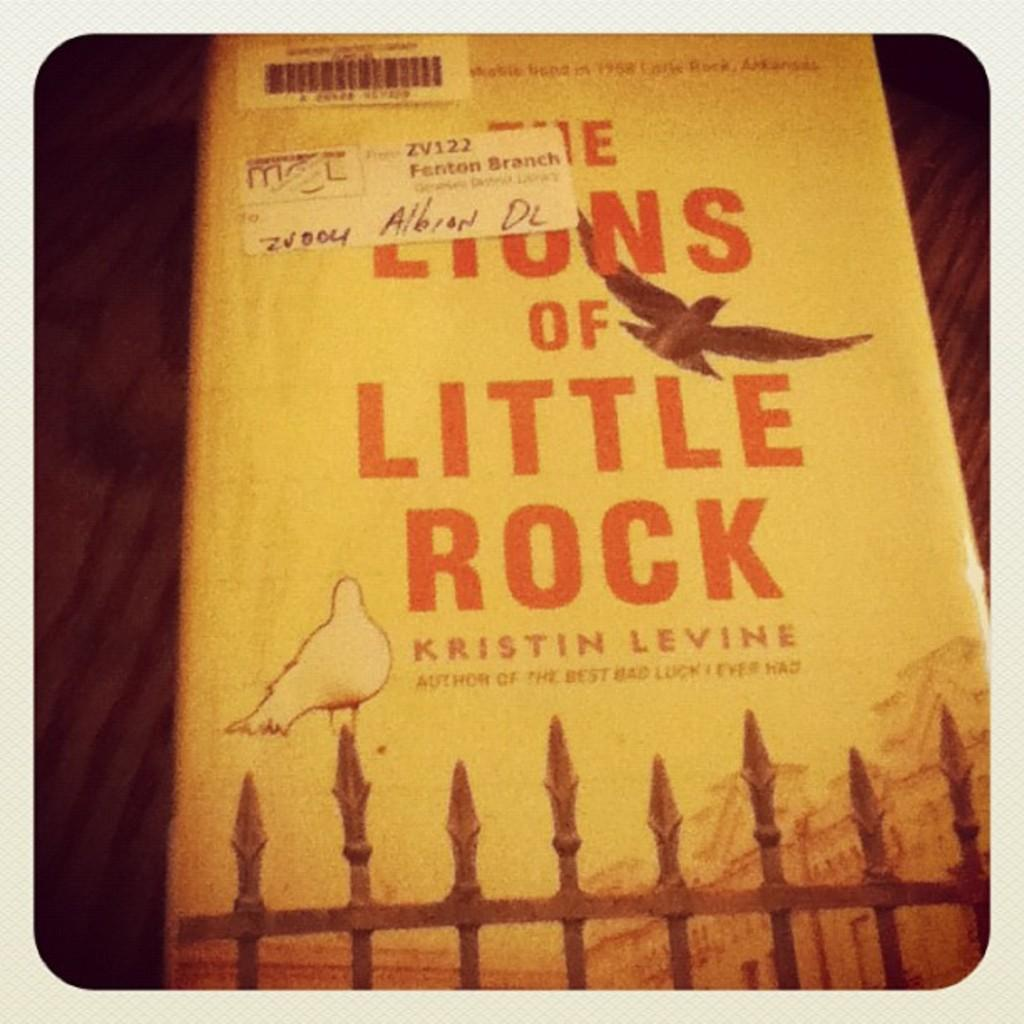Provide a one-sentence caption for the provided image. A book by Kristin Levine has a yellow cover with birds on it. 